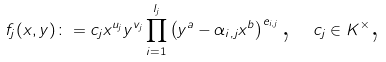Convert formula to latex. <formula><loc_0><loc_0><loc_500><loc_500>f _ { j } ( x , y ) \colon = c _ { j } x ^ { u _ { j } } y ^ { v _ { j } } \prod _ { i = 1 } ^ { l _ { j } } \left ( y ^ { a } - \alpha _ { i , j } x ^ { b } \right ) ^ { e _ { i , j } } \text {, \ } c _ { j } \in K ^ { \times } \text {,}</formula> 